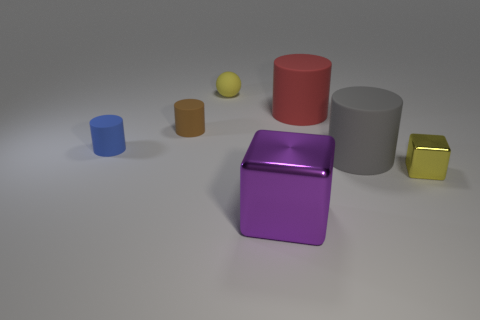Add 2 matte cylinders. How many objects exist? 9 Subtract 3 cylinders. How many cylinders are left? 1 Subtract all spheres. How many objects are left? 6 Subtract all blue cylinders. How many cylinders are left? 3 Add 5 red things. How many red things are left? 6 Add 6 big cyan cubes. How many big cyan cubes exist? 6 Subtract 1 gray cylinders. How many objects are left? 6 Subtract all purple cubes. Subtract all brown balls. How many cubes are left? 1 Subtract all yellow spheres. Subtract all small yellow balls. How many objects are left? 5 